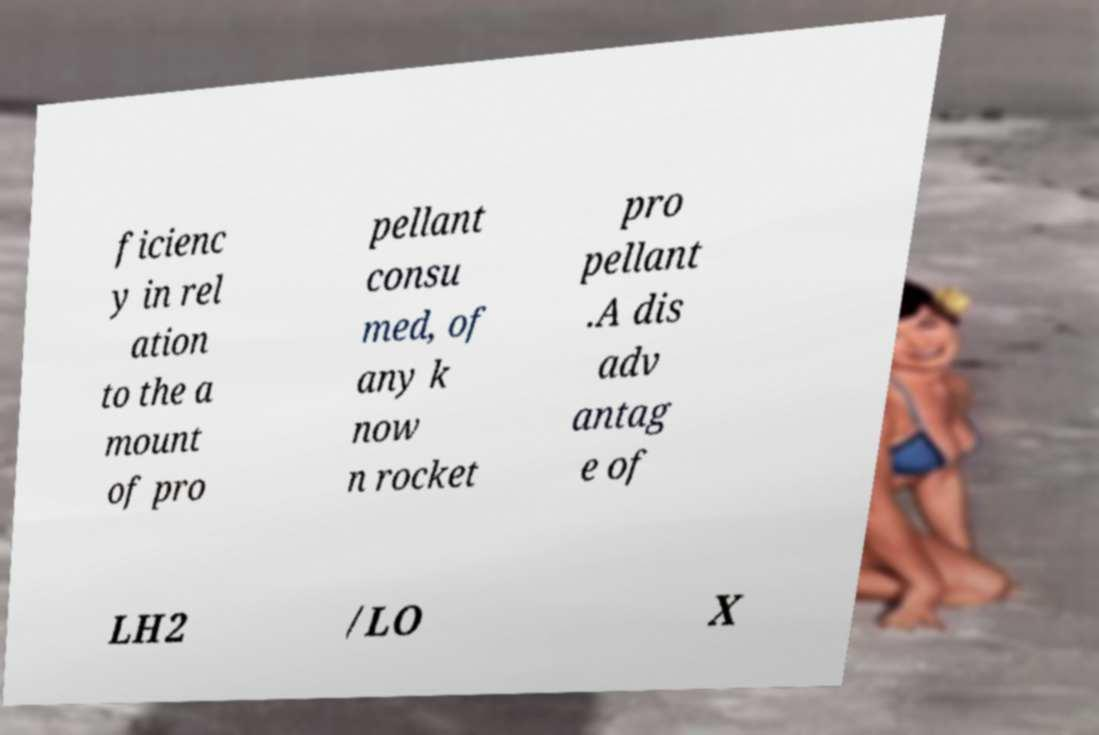I need the written content from this picture converted into text. Can you do that? ficienc y in rel ation to the a mount of pro pellant consu med, of any k now n rocket pro pellant .A dis adv antag e of LH2 /LO X 